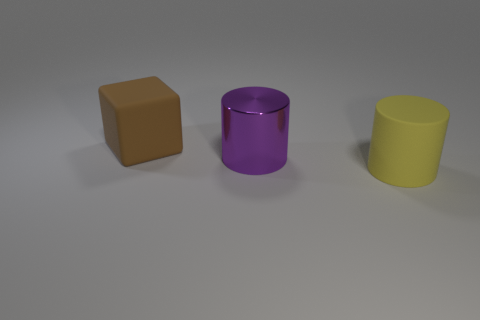Add 2 small blue matte objects. How many objects exist? 5 Subtract all cylinders. How many objects are left? 1 Add 2 large cylinders. How many large cylinders exist? 4 Subtract 0 gray cylinders. How many objects are left? 3 Subtract all large yellow matte cylinders. Subtract all red metal cylinders. How many objects are left? 2 Add 2 large shiny cylinders. How many large shiny cylinders are left? 3 